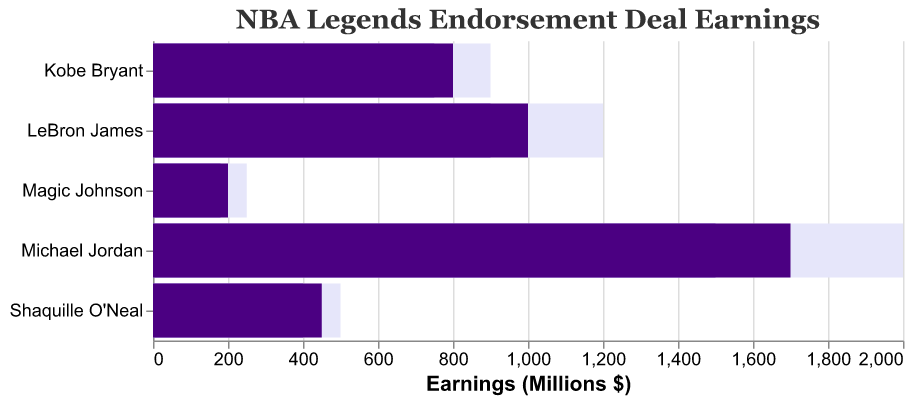Which player has the greatest actual endorsement deal earnings? The title "NBA Legends Endorsement Deal Earnings" and the bar lengths indicate the earnings. Michael Jordan's bar for actual earnings is the longest.
Answer: Michael Jordan How much higher is Shaquille O'Neal's actual earnings compared to his comparative earnings? Shaquille O'Neal's actual earnings are marked at 450 million dollars, and his comparative earnings are marked at 400 million dollars. The difference is 450 - 400.
Answer: 50 million dollars What is the sum of the comparative earnings for Kobe Bryant and Magic Johnson? Kobe Bryant's comparative earnings are marked at 750 million dollars, and Magic Johnson's at 180 million dollars. Adding these values gives us a sum of 750 + 180.
Answer: 930 million dollars Which player's actual earnings are closest to their target earnings? Shaquille O'Neal's actual earnings are 450 million dollars with a target of 500, Michael Jordan's actual earnings are 1700 million dollars with a target of 2000, LeBron James' actual earnings are 1000 million dollars with a target of 1200, Kobe Bryant's actual earnings are 800 million dollars with a target of 900, and Magic Johnson's actual earnings are 200 million dollars with a target of 250. The smallest difference is for Kobe Bryant, which is 900 - 800.
Answer: Kobe Bryant By how much does LeBron James' actual earnings exceed Magic Johnson's actual earnings? LeBron James' actual earnings are marked at 1000 million dollars, and Magic Johnson's actual earnings are marked at 200 million dollars. The difference is 1000 - 200.
Answer: 800 million dollars How far is Shaquille O'Neal from reaching his endorsement earnings target? Shaquille O'Neal's actual earnings are 450 million dollars, and his target is 500 million dollars. The difference is 500 - 450.
Answer: 50 million dollars Which player has the smallest difference between their comparative and target earnings? Shaquille O'Neal's difference is 500 - 400, Michael Jordan's difference is 2000 - 1500, LeBron James' difference is 1200 - 900, Kobe Bryant's difference is 900 - 750, and Magic Johnson's difference is 250 - 180. The smallest difference is for Magic Johnson.
Answer: Magic Johnson 